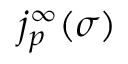<formula> <loc_0><loc_0><loc_500><loc_500>j _ { p } ^ { \infty } ( \sigma )</formula> 